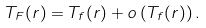<formula> <loc_0><loc_0><loc_500><loc_500>T _ { F } ( r ) = T _ { f } ( r ) + o \left ( T _ { f } ( r ) \right ) .</formula> 